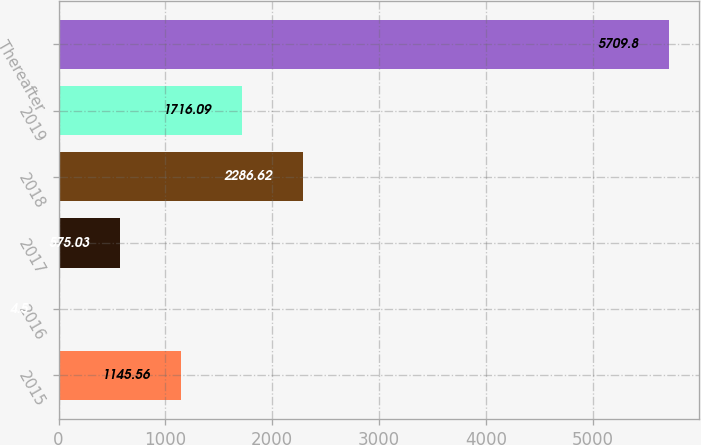Convert chart to OTSL. <chart><loc_0><loc_0><loc_500><loc_500><bar_chart><fcel>2015<fcel>2016<fcel>2017<fcel>2018<fcel>2019<fcel>Thereafter<nl><fcel>1145.56<fcel>4.5<fcel>575.03<fcel>2286.62<fcel>1716.09<fcel>5709.8<nl></chart> 